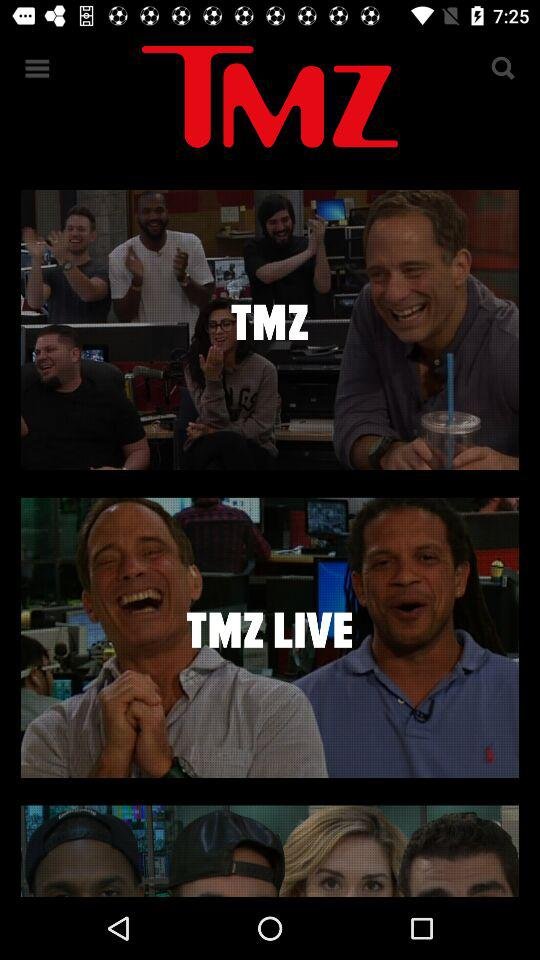What is the name of the application? The name of the application is "TMZ". 